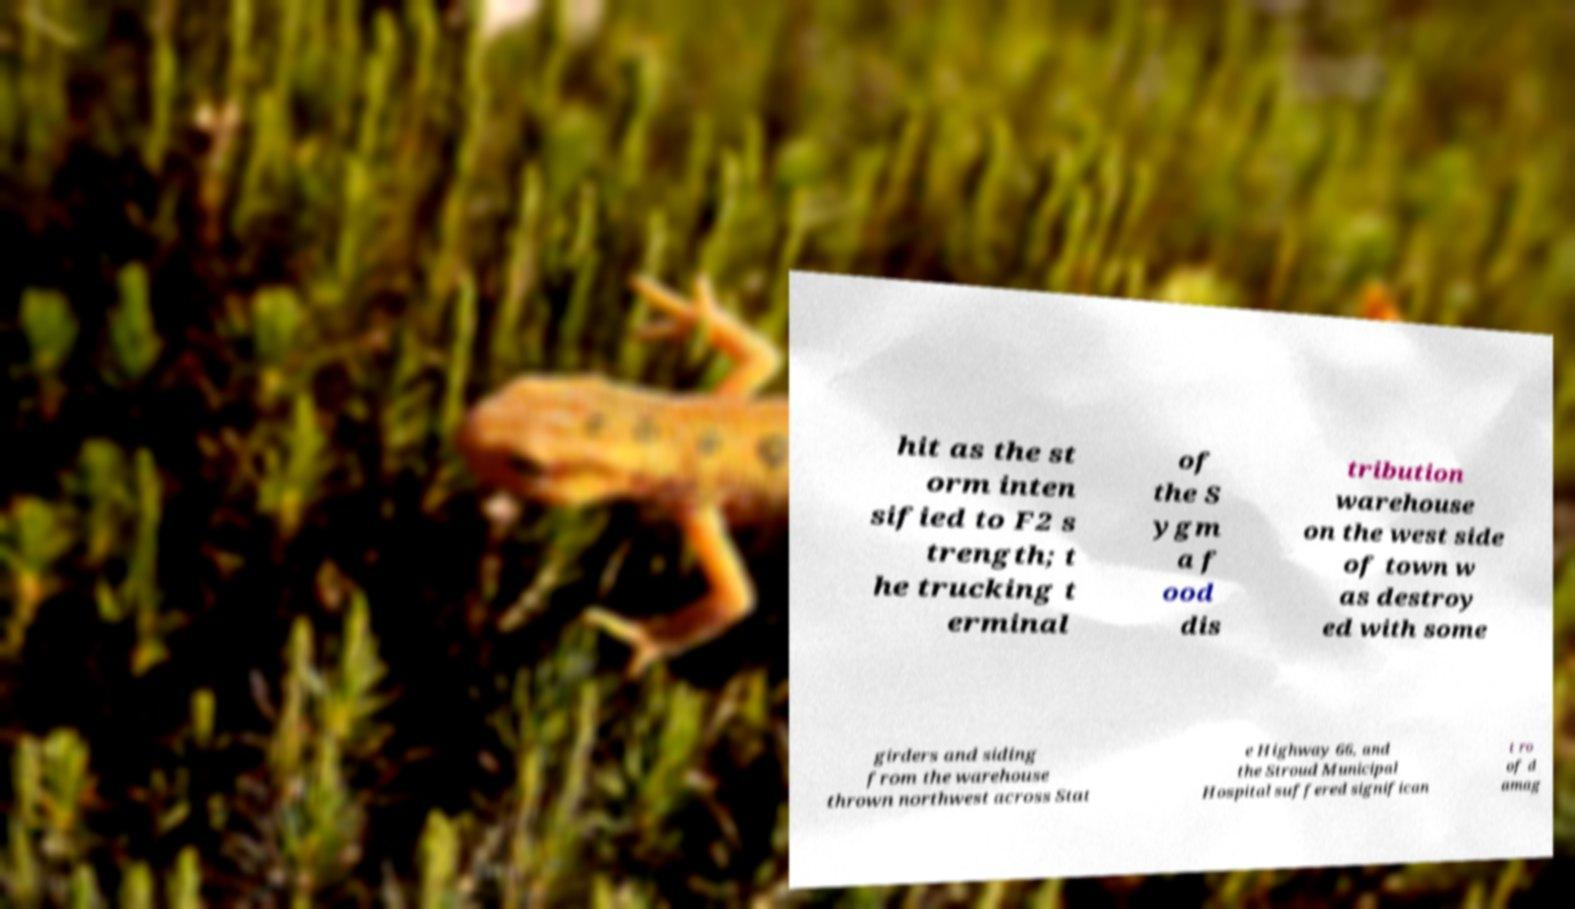I need the written content from this picture converted into text. Can you do that? hit as the st orm inten sified to F2 s trength; t he trucking t erminal of the S ygm a f ood dis tribution warehouse on the west side of town w as destroy ed with some girders and siding from the warehouse thrown northwest across Stat e Highway 66, and the Stroud Municipal Hospital suffered significan t ro of d amag 